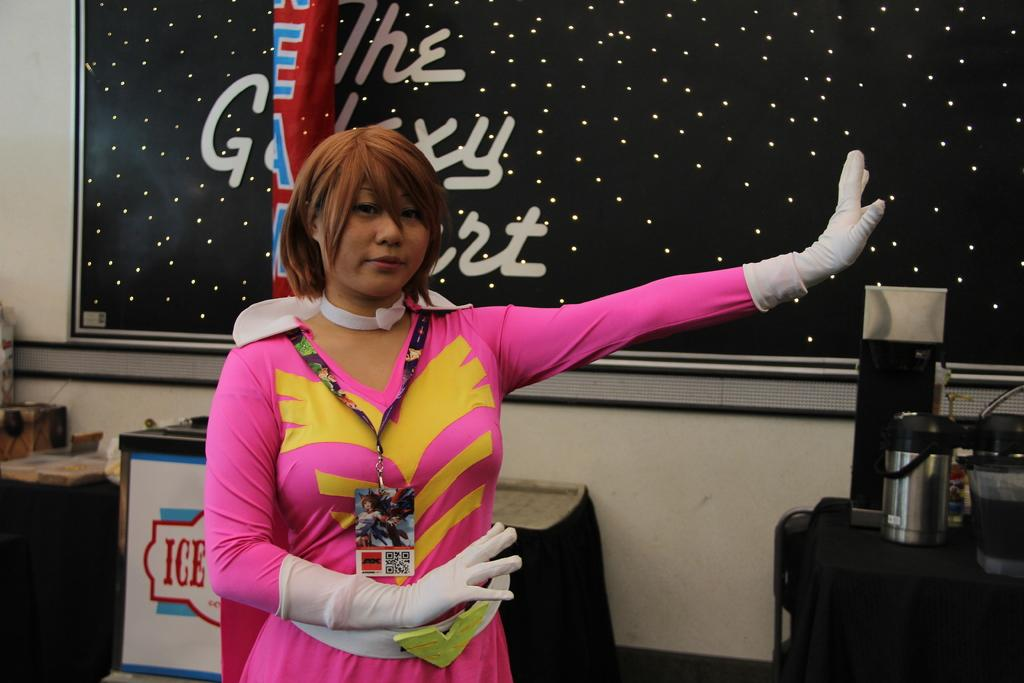What is the main subject of the image? There is a person in the image. What is the person wearing? The person is wearing a pink dress and white gloves. Does the person have any identification in the image? Yes, the person has an id card. What can be seen in the background of the image? There are tables and a blackboard in the background of the image. What type of jam is being spread on the person's nose in the image? There is no jam or any activity involving the person's nose in the image. 